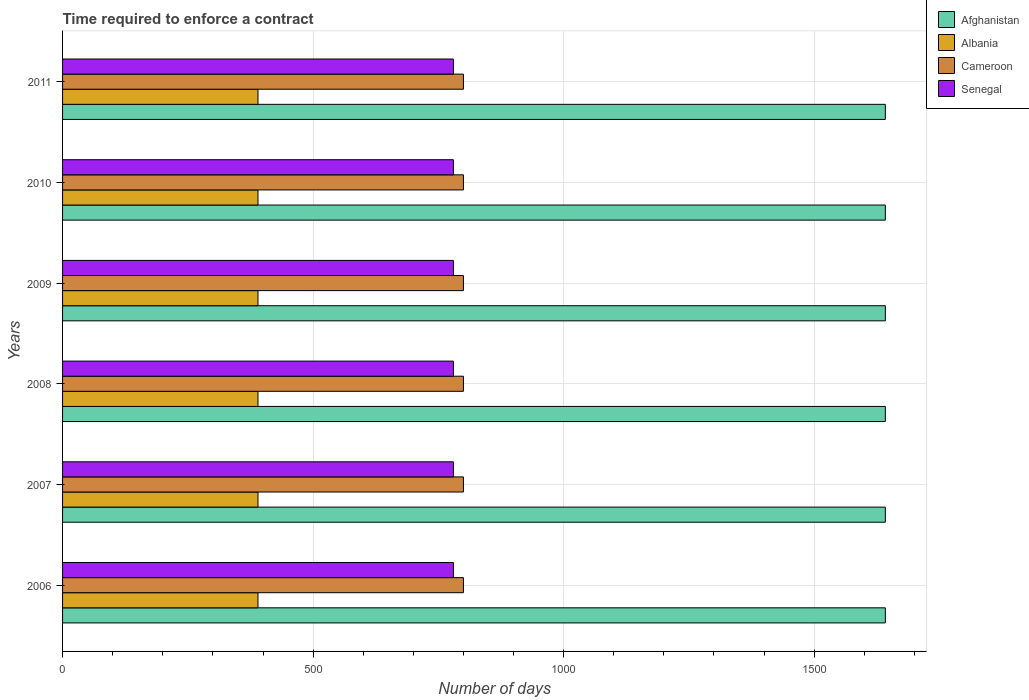How many different coloured bars are there?
Your answer should be compact. 4. How many bars are there on the 1st tick from the top?
Ensure brevity in your answer.  4. In how many cases, is the number of bars for a given year not equal to the number of legend labels?
Make the answer very short. 0. What is the number of days required to enforce a contract in Albania in 2008?
Provide a short and direct response. 390. Across all years, what is the maximum number of days required to enforce a contract in Afghanistan?
Offer a very short reply. 1642. Across all years, what is the minimum number of days required to enforce a contract in Afghanistan?
Offer a terse response. 1642. What is the total number of days required to enforce a contract in Cameroon in the graph?
Provide a short and direct response. 4800. What is the difference between the number of days required to enforce a contract in Cameroon in 2009 and the number of days required to enforce a contract in Senegal in 2008?
Your answer should be very brief. 20. What is the average number of days required to enforce a contract in Albania per year?
Provide a short and direct response. 390. In the year 2009, what is the difference between the number of days required to enforce a contract in Cameroon and number of days required to enforce a contract in Albania?
Keep it short and to the point. 410. What is the ratio of the number of days required to enforce a contract in Albania in 2008 to that in 2010?
Keep it short and to the point. 1. Is the difference between the number of days required to enforce a contract in Cameroon in 2006 and 2011 greater than the difference between the number of days required to enforce a contract in Albania in 2006 and 2011?
Offer a very short reply. No. Is the sum of the number of days required to enforce a contract in Senegal in 2006 and 2010 greater than the maximum number of days required to enforce a contract in Afghanistan across all years?
Keep it short and to the point. No. Is it the case that in every year, the sum of the number of days required to enforce a contract in Senegal and number of days required to enforce a contract in Albania is greater than the sum of number of days required to enforce a contract in Afghanistan and number of days required to enforce a contract in Cameroon?
Offer a very short reply. Yes. What does the 3rd bar from the top in 2008 represents?
Your response must be concise. Albania. What does the 3rd bar from the bottom in 2010 represents?
Provide a succinct answer. Cameroon. How many bars are there?
Give a very brief answer. 24. Are all the bars in the graph horizontal?
Your answer should be very brief. Yes. Are the values on the major ticks of X-axis written in scientific E-notation?
Offer a very short reply. No. Does the graph contain grids?
Your response must be concise. Yes. Where does the legend appear in the graph?
Give a very brief answer. Top right. How are the legend labels stacked?
Provide a succinct answer. Vertical. What is the title of the graph?
Your answer should be compact. Time required to enforce a contract. What is the label or title of the X-axis?
Keep it short and to the point. Number of days. What is the label or title of the Y-axis?
Give a very brief answer. Years. What is the Number of days in Afghanistan in 2006?
Provide a short and direct response. 1642. What is the Number of days in Albania in 2006?
Provide a succinct answer. 390. What is the Number of days in Cameroon in 2006?
Your response must be concise. 800. What is the Number of days in Senegal in 2006?
Keep it short and to the point. 780. What is the Number of days of Afghanistan in 2007?
Keep it short and to the point. 1642. What is the Number of days of Albania in 2007?
Keep it short and to the point. 390. What is the Number of days of Cameroon in 2007?
Provide a succinct answer. 800. What is the Number of days of Senegal in 2007?
Give a very brief answer. 780. What is the Number of days of Afghanistan in 2008?
Offer a terse response. 1642. What is the Number of days of Albania in 2008?
Ensure brevity in your answer.  390. What is the Number of days of Cameroon in 2008?
Your answer should be very brief. 800. What is the Number of days of Senegal in 2008?
Make the answer very short. 780. What is the Number of days of Afghanistan in 2009?
Provide a succinct answer. 1642. What is the Number of days of Albania in 2009?
Your answer should be very brief. 390. What is the Number of days of Cameroon in 2009?
Your answer should be compact. 800. What is the Number of days in Senegal in 2009?
Offer a terse response. 780. What is the Number of days of Afghanistan in 2010?
Offer a terse response. 1642. What is the Number of days of Albania in 2010?
Make the answer very short. 390. What is the Number of days in Cameroon in 2010?
Your response must be concise. 800. What is the Number of days of Senegal in 2010?
Offer a terse response. 780. What is the Number of days in Afghanistan in 2011?
Provide a short and direct response. 1642. What is the Number of days of Albania in 2011?
Give a very brief answer. 390. What is the Number of days in Cameroon in 2011?
Ensure brevity in your answer.  800. What is the Number of days of Senegal in 2011?
Provide a succinct answer. 780. Across all years, what is the maximum Number of days in Afghanistan?
Offer a terse response. 1642. Across all years, what is the maximum Number of days in Albania?
Make the answer very short. 390. Across all years, what is the maximum Number of days in Cameroon?
Provide a succinct answer. 800. Across all years, what is the maximum Number of days in Senegal?
Offer a terse response. 780. Across all years, what is the minimum Number of days in Afghanistan?
Make the answer very short. 1642. Across all years, what is the minimum Number of days in Albania?
Give a very brief answer. 390. Across all years, what is the minimum Number of days in Cameroon?
Your answer should be very brief. 800. Across all years, what is the minimum Number of days of Senegal?
Keep it short and to the point. 780. What is the total Number of days in Afghanistan in the graph?
Your answer should be compact. 9852. What is the total Number of days of Albania in the graph?
Provide a succinct answer. 2340. What is the total Number of days in Cameroon in the graph?
Make the answer very short. 4800. What is the total Number of days of Senegal in the graph?
Your answer should be very brief. 4680. What is the difference between the Number of days of Afghanistan in 2006 and that in 2007?
Provide a succinct answer. 0. What is the difference between the Number of days in Cameroon in 2006 and that in 2008?
Give a very brief answer. 0. What is the difference between the Number of days in Senegal in 2006 and that in 2008?
Your response must be concise. 0. What is the difference between the Number of days of Senegal in 2006 and that in 2009?
Your answer should be compact. 0. What is the difference between the Number of days of Cameroon in 2006 and that in 2010?
Offer a terse response. 0. What is the difference between the Number of days in Senegal in 2006 and that in 2010?
Your response must be concise. 0. What is the difference between the Number of days of Senegal in 2007 and that in 2008?
Your response must be concise. 0. What is the difference between the Number of days in Albania in 2007 and that in 2009?
Offer a terse response. 0. What is the difference between the Number of days in Senegal in 2007 and that in 2009?
Provide a succinct answer. 0. What is the difference between the Number of days in Cameroon in 2007 and that in 2010?
Keep it short and to the point. 0. What is the difference between the Number of days in Senegal in 2007 and that in 2010?
Provide a short and direct response. 0. What is the difference between the Number of days in Afghanistan in 2007 and that in 2011?
Offer a terse response. 0. What is the difference between the Number of days of Albania in 2008 and that in 2009?
Make the answer very short. 0. What is the difference between the Number of days in Cameroon in 2008 and that in 2009?
Ensure brevity in your answer.  0. What is the difference between the Number of days of Afghanistan in 2008 and that in 2010?
Your answer should be very brief. 0. What is the difference between the Number of days in Cameroon in 2008 and that in 2010?
Offer a terse response. 0. What is the difference between the Number of days of Afghanistan in 2008 and that in 2011?
Your answer should be compact. 0. What is the difference between the Number of days in Albania in 2008 and that in 2011?
Offer a very short reply. 0. What is the difference between the Number of days in Senegal in 2008 and that in 2011?
Offer a terse response. 0. What is the difference between the Number of days of Afghanistan in 2009 and that in 2010?
Offer a very short reply. 0. What is the difference between the Number of days of Albania in 2009 and that in 2010?
Provide a short and direct response. 0. What is the difference between the Number of days in Senegal in 2009 and that in 2010?
Make the answer very short. 0. What is the difference between the Number of days in Afghanistan in 2009 and that in 2011?
Give a very brief answer. 0. What is the difference between the Number of days of Albania in 2009 and that in 2011?
Provide a succinct answer. 0. What is the difference between the Number of days in Cameroon in 2009 and that in 2011?
Your response must be concise. 0. What is the difference between the Number of days in Senegal in 2009 and that in 2011?
Give a very brief answer. 0. What is the difference between the Number of days in Afghanistan in 2010 and that in 2011?
Your answer should be compact. 0. What is the difference between the Number of days in Senegal in 2010 and that in 2011?
Provide a short and direct response. 0. What is the difference between the Number of days of Afghanistan in 2006 and the Number of days of Albania in 2007?
Make the answer very short. 1252. What is the difference between the Number of days of Afghanistan in 2006 and the Number of days of Cameroon in 2007?
Keep it short and to the point. 842. What is the difference between the Number of days in Afghanistan in 2006 and the Number of days in Senegal in 2007?
Your answer should be compact. 862. What is the difference between the Number of days of Albania in 2006 and the Number of days of Cameroon in 2007?
Your answer should be compact. -410. What is the difference between the Number of days in Albania in 2006 and the Number of days in Senegal in 2007?
Offer a very short reply. -390. What is the difference between the Number of days of Afghanistan in 2006 and the Number of days of Albania in 2008?
Your answer should be compact. 1252. What is the difference between the Number of days in Afghanistan in 2006 and the Number of days in Cameroon in 2008?
Provide a succinct answer. 842. What is the difference between the Number of days of Afghanistan in 2006 and the Number of days of Senegal in 2008?
Your response must be concise. 862. What is the difference between the Number of days in Albania in 2006 and the Number of days in Cameroon in 2008?
Keep it short and to the point. -410. What is the difference between the Number of days in Albania in 2006 and the Number of days in Senegal in 2008?
Ensure brevity in your answer.  -390. What is the difference between the Number of days of Afghanistan in 2006 and the Number of days of Albania in 2009?
Provide a succinct answer. 1252. What is the difference between the Number of days of Afghanistan in 2006 and the Number of days of Cameroon in 2009?
Offer a very short reply. 842. What is the difference between the Number of days of Afghanistan in 2006 and the Number of days of Senegal in 2009?
Your answer should be very brief. 862. What is the difference between the Number of days of Albania in 2006 and the Number of days of Cameroon in 2009?
Keep it short and to the point. -410. What is the difference between the Number of days in Albania in 2006 and the Number of days in Senegal in 2009?
Ensure brevity in your answer.  -390. What is the difference between the Number of days of Cameroon in 2006 and the Number of days of Senegal in 2009?
Ensure brevity in your answer.  20. What is the difference between the Number of days in Afghanistan in 2006 and the Number of days in Albania in 2010?
Offer a very short reply. 1252. What is the difference between the Number of days in Afghanistan in 2006 and the Number of days in Cameroon in 2010?
Make the answer very short. 842. What is the difference between the Number of days of Afghanistan in 2006 and the Number of days of Senegal in 2010?
Give a very brief answer. 862. What is the difference between the Number of days of Albania in 2006 and the Number of days of Cameroon in 2010?
Keep it short and to the point. -410. What is the difference between the Number of days of Albania in 2006 and the Number of days of Senegal in 2010?
Offer a very short reply. -390. What is the difference between the Number of days of Cameroon in 2006 and the Number of days of Senegal in 2010?
Your response must be concise. 20. What is the difference between the Number of days of Afghanistan in 2006 and the Number of days of Albania in 2011?
Provide a short and direct response. 1252. What is the difference between the Number of days of Afghanistan in 2006 and the Number of days of Cameroon in 2011?
Ensure brevity in your answer.  842. What is the difference between the Number of days of Afghanistan in 2006 and the Number of days of Senegal in 2011?
Offer a terse response. 862. What is the difference between the Number of days in Albania in 2006 and the Number of days in Cameroon in 2011?
Make the answer very short. -410. What is the difference between the Number of days in Albania in 2006 and the Number of days in Senegal in 2011?
Give a very brief answer. -390. What is the difference between the Number of days of Afghanistan in 2007 and the Number of days of Albania in 2008?
Make the answer very short. 1252. What is the difference between the Number of days of Afghanistan in 2007 and the Number of days of Cameroon in 2008?
Offer a very short reply. 842. What is the difference between the Number of days of Afghanistan in 2007 and the Number of days of Senegal in 2008?
Give a very brief answer. 862. What is the difference between the Number of days in Albania in 2007 and the Number of days in Cameroon in 2008?
Offer a terse response. -410. What is the difference between the Number of days in Albania in 2007 and the Number of days in Senegal in 2008?
Keep it short and to the point. -390. What is the difference between the Number of days of Afghanistan in 2007 and the Number of days of Albania in 2009?
Offer a terse response. 1252. What is the difference between the Number of days in Afghanistan in 2007 and the Number of days in Cameroon in 2009?
Your response must be concise. 842. What is the difference between the Number of days of Afghanistan in 2007 and the Number of days of Senegal in 2009?
Your response must be concise. 862. What is the difference between the Number of days of Albania in 2007 and the Number of days of Cameroon in 2009?
Keep it short and to the point. -410. What is the difference between the Number of days of Albania in 2007 and the Number of days of Senegal in 2009?
Your answer should be compact. -390. What is the difference between the Number of days of Afghanistan in 2007 and the Number of days of Albania in 2010?
Ensure brevity in your answer.  1252. What is the difference between the Number of days of Afghanistan in 2007 and the Number of days of Cameroon in 2010?
Provide a succinct answer. 842. What is the difference between the Number of days in Afghanistan in 2007 and the Number of days in Senegal in 2010?
Make the answer very short. 862. What is the difference between the Number of days of Albania in 2007 and the Number of days of Cameroon in 2010?
Offer a terse response. -410. What is the difference between the Number of days of Albania in 2007 and the Number of days of Senegal in 2010?
Provide a succinct answer. -390. What is the difference between the Number of days of Cameroon in 2007 and the Number of days of Senegal in 2010?
Your answer should be compact. 20. What is the difference between the Number of days in Afghanistan in 2007 and the Number of days in Albania in 2011?
Keep it short and to the point. 1252. What is the difference between the Number of days in Afghanistan in 2007 and the Number of days in Cameroon in 2011?
Your answer should be very brief. 842. What is the difference between the Number of days of Afghanistan in 2007 and the Number of days of Senegal in 2011?
Provide a succinct answer. 862. What is the difference between the Number of days in Albania in 2007 and the Number of days in Cameroon in 2011?
Your answer should be compact. -410. What is the difference between the Number of days in Albania in 2007 and the Number of days in Senegal in 2011?
Provide a short and direct response. -390. What is the difference between the Number of days of Cameroon in 2007 and the Number of days of Senegal in 2011?
Your answer should be very brief. 20. What is the difference between the Number of days in Afghanistan in 2008 and the Number of days in Albania in 2009?
Provide a short and direct response. 1252. What is the difference between the Number of days in Afghanistan in 2008 and the Number of days in Cameroon in 2009?
Offer a very short reply. 842. What is the difference between the Number of days in Afghanistan in 2008 and the Number of days in Senegal in 2009?
Your response must be concise. 862. What is the difference between the Number of days in Albania in 2008 and the Number of days in Cameroon in 2009?
Offer a very short reply. -410. What is the difference between the Number of days in Albania in 2008 and the Number of days in Senegal in 2009?
Give a very brief answer. -390. What is the difference between the Number of days of Cameroon in 2008 and the Number of days of Senegal in 2009?
Your answer should be compact. 20. What is the difference between the Number of days of Afghanistan in 2008 and the Number of days of Albania in 2010?
Offer a very short reply. 1252. What is the difference between the Number of days in Afghanistan in 2008 and the Number of days in Cameroon in 2010?
Give a very brief answer. 842. What is the difference between the Number of days in Afghanistan in 2008 and the Number of days in Senegal in 2010?
Keep it short and to the point. 862. What is the difference between the Number of days of Albania in 2008 and the Number of days of Cameroon in 2010?
Make the answer very short. -410. What is the difference between the Number of days in Albania in 2008 and the Number of days in Senegal in 2010?
Offer a very short reply. -390. What is the difference between the Number of days in Cameroon in 2008 and the Number of days in Senegal in 2010?
Give a very brief answer. 20. What is the difference between the Number of days in Afghanistan in 2008 and the Number of days in Albania in 2011?
Your answer should be compact. 1252. What is the difference between the Number of days in Afghanistan in 2008 and the Number of days in Cameroon in 2011?
Ensure brevity in your answer.  842. What is the difference between the Number of days in Afghanistan in 2008 and the Number of days in Senegal in 2011?
Provide a succinct answer. 862. What is the difference between the Number of days of Albania in 2008 and the Number of days of Cameroon in 2011?
Offer a terse response. -410. What is the difference between the Number of days in Albania in 2008 and the Number of days in Senegal in 2011?
Offer a very short reply. -390. What is the difference between the Number of days in Afghanistan in 2009 and the Number of days in Albania in 2010?
Your answer should be very brief. 1252. What is the difference between the Number of days of Afghanistan in 2009 and the Number of days of Cameroon in 2010?
Your answer should be very brief. 842. What is the difference between the Number of days of Afghanistan in 2009 and the Number of days of Senegal in 2010?
Your answer should be compact. 862. What is the difference between the Number of days of Albania in 2009 and the Number of days of Cameroon in 2010?
Offer a very short reply. -410. What is the difference between the Number of days in Albania in 2009 and the Number of days in Senegal in 2010?
Provide a short and direct response. -390. What is the difference between the Number of days of Cameroon in 2009 and the Number of days of Senegal in 2010?
Offer a very short reply. 20. What is the difference between the Number of days of Afghanistan in 2009 and the Number of days of Albania in 2011?
Offer a terse response. 1252. What is the difference between the Number of days in Afghanistan in 2009 and the Number of days in Cameroon in 2011?
Provide a short and direct response. 842. What is the difference between the Number of days of Afghanistan in 2009 and the Number of days of Senegal in 2011?
Give a very brief answer. 862. What is the difference between the Number of days of Albania in 2009 and the Number of days of Cameroon in 2011?
Your answer should be compact. -410. What is the difference between the Number of days of Albania in 2009 and the Number of days of Senegal in 2011?
Keep it short and to the point. -390. What is the difference between the Number of days in Cameroon in 2009 and the Number of days in Senegal in 2011?
Provide a short and direct response. 20. What is the difference between the Number of days in Afghanistan in 2010 and the Number of days in Albania in 2011?
Offer a terse response. 1252. What is the difference between the Number of days in Afghanistan in 2010 and the Number of days in Cameroon in 2011?
Give a very brief answer. 842. What is the difference between the Number of days in Afghanistan in 2010 and the Number of days in Senegal in 2011?
Provide a short and direct response. 862. What is the difference between the Number of days of Albania in 2010 and the Number of days of Cameroon in 2011?
Offer a terse response. -410. What is the difference between the Number of days of Albania in 2010 and the Number of days of Senegal in 2011?
Ensure brevity in your answer.  -390. What is the average Number of days of Afghanistan per year?
Make the answer very short. 1642. What is the average Number of days in Albania per year?
Give a very brief answer. 390. What is the average Number of days of Cameroon per year?
Give a very brief answer. 800. What is the average Number of days in Senegal per year?
Ensure brevity in your answer.  780. In the year 2006, what is the difference between the Number of days in Afghanistan and Number of days in Albania?
Your answer should be very brief. 1252. In the year 2006, what is the difference between the Number of days of Afghanistan and Number of days of Cameroon?
Give a very brief answer. 842. In the year 2006, what is the difference between the Number of days in Afghanistan and Number of days in Senegal?
Keep it short and to the point. 862. In the year 2006, what is the difference between the Number of days of Albania and Number of days of Cameroon?
Ensure brevity in your answer.  -410. In the year 2006, what is the difference between the Number of days in Albania and Number of days in Senegal?
Give a very brief answer. -390. In the year 2006, what is the difference between the Number of days of Cameroon and Number of days of Senegal?
Offer a terse response. 20. In the year 2007, what is the difference between the Number of days in Afghanistan and Number of days in Albania?
Provide a succinct answer. 1252. In the year 2007, what is the difference between the Number of days in Afghanistan and Number of days in Cameroon?
Ensure brevity in your answer.  842. In the year 2007, what is the difference between the Number of days of Afghanistan and Number of days of Senegal?
Your answer should be compact. 862. In the year 2007, what is the difference between the Number of days in Albania and Number of days in Cameroon?
Give a very brief answer. -410. In the year 2007, what is the difference between the Number of days of Albania and Number of days of Senegal?
Make the answer very short. -390. In the year 2007, what is the difference between the Number of days of Cameroon and Number of days of Senegal?
Make the answer very short. 20. In the year 2008, what is the difference between the Number of days of Afghanistan and Number of days of Albania?
Offer a very short reply. 1252. In the year 2008, what is the difference between the Number of days in Afghanistan and Number of days in Cameroon?
Give a very brief answer. 842. In the year 2008, what is the difference between the Number of days in Afghanistan and Number of days in Senegal?
Make the answer very short. 862. In the year 2008, what is the difference between the Number of days of Albania and Number of days of Cameroon?
Your response must be concise. -410. In the year 2008, what is the difference between the Number of days of Albania and Number of days of Senegal?
Ensure brevity in your answer.  -390. In the year 2008, what is the difference between the Number of days of Cameroon and Number of days of Senegal?
Provide a short and direct response. 20. In the year 2009, what is the difference between the Number of days in Afghanistan and Number of days in Albania?
Your answer should be very brief. 1252. In the year 2009, what is the difference between the Number of days in Afghanistan and Number of days in Cameroon?
Your answer should be compact. 842. In the year 2009, what is the difference between the Number of days in Afghanistan and Number of days in Senegal?
Your answer should be very brief. 862. In the year 2009, what is the difference between the Number of days of Albania and Number of days of Cameroon?
Offer a terse response. -410. In the year 2009, what is the difference between the Number of days in Albania and Number of days in Senegal?
Provide a succinct answer. -390. In the year 2009, what is the difference between the Number of days of Cameroon and Number of days of Senegal?
Your response must be concise. 20. In the year 2010, what is the difference between the Number of days of Afghanistan and Number of days of Albania?
Keep it short and to the point. 1252. In the year 2010, what is the difference between the Number of days in Afghanistan and Number of days in Cameroon?
Make the answer very short. 842. In the year 2010, what is the difference between the Number of days of Afghanistan and Number of days of Senegal?
Your response must be concise. 862. In the year 2010, what is the difference between the Number of days of Albania and Number of days of Cameroon?
Offer a terse response. -410. In the year 2010, what is the difference between the Number of days of Albania and Number of days of Senegal?
Provide a short and direct response. -390. In the year 2010, what is the difference between the Number of days of Cameroon and Number of days of Senegal?
Make the answer very short. 20. In the year 2011, what is the difference between the Number of days in Afghanistan and Number of days in Albania?
Your response must be concise. 1252. In the year 2011, what is the difference between the Number of days of Afghanistan and Number of days of Cameroon?
Provide a short and direct response. 842. In the year 2011, what is the difference between the Number of days in Afghanistan and Number of days in Senegal?
Give a very brief answer. 862. In the year 2011, what is the difference between the Number of days in Albania and Number of days in Cameroon?
Provide a succinct answer. -410. In the year 2011, what is the difference between the Number of days of Albania and Number of days of Senegal?
Ensure brevity in your answer.  -390. What is the ratio of the Number of days in Afghanistan in 2006 to that in 2008?
Give a very brief answer. 1. What is the ratio of the Number of days in Afghanistan in 2006 to that in 2009?
Ensure brevity in your answer.  1. What is the ratio of the Number of days of Cameroon in 2006 to that in 2009?
Keep it short and to the point. 1. What is the ratio of the Number of days of Cameroon in 2006 to that in 2010?
Ensure brevity in your answer.  1. What is the ratio of the Number of days of Senegal in 2006 to that in 2011?
Your answer should be compact. 1. What is the ratio of the Number of days in Afghanistan in 2007 to that in 2008?
Give a very brief answer. 1. What is the ratio of the Number of days in Albania in 2007 to that in 2008?
Offer a very short reply. 1. What is the ratio of the Number of days in Senegal in 2007 to that in 2010?
Give a very brief answer. 1. What is the ratio of the Number of days of Afghanistan in 2007 to that in 2011?
Give a very brief answer. 1. What is the ratio of the Number of days in Albania in 2008 to that in 2009?
Make the answer very short. 1. What is the ratio of the Number of days in Cameroon in 2008 to that in 2009?
Give a very brief answer. 1. What is the ratio of the Number of days of Senegal in 2008 to that in 2009?
Give a very brief answer. 1. What is the ratio of the Number of days of Cameroon in 2008 to that in 2010?
Offer a very short reply. 1. What is the ratio of the Number of days of Afghanistan in 2008 to that in 2011?
Your response must be concise. 1. What is the ratio of the Number of days of Senegal in 2008 to that in 2011?
Offer a terse response. 1. What is the ratio of the Number of days in Albania in 2009 to that in 2010?
Keep it short and to the point. 1. What is the ratio of the Number of days of Cameroon in 2009 to that in 2010?
Your answer should be very brief. 1. What is the ratio of the Number of days of Afghanistan in 2009 to that in 2011?
Ensure brevity in your answer.  1. What is the ratio of the Number of days of Cameroon in 2009 to that in 2011?
Your answer should be very brief. 1. What is the ratio of the Number of days in Albania in 2010 to that in 2011?
Ensure brevity in your answer.  1. What is the ratio of the Number of days in Cameroon in 2010 to that in 2011?
Keep it short and to the point. 1. What is the difference between the highest and the second highest Number of days of Albania?
Keep it short and to the point. 0. What is the difference between the highest and the second highest Number of days of Senegal?
Ensure brevity in your answer.  0. What is the difference between the highest and the lowest Number of days of Senegal?
Offer a very short reply. 0. 